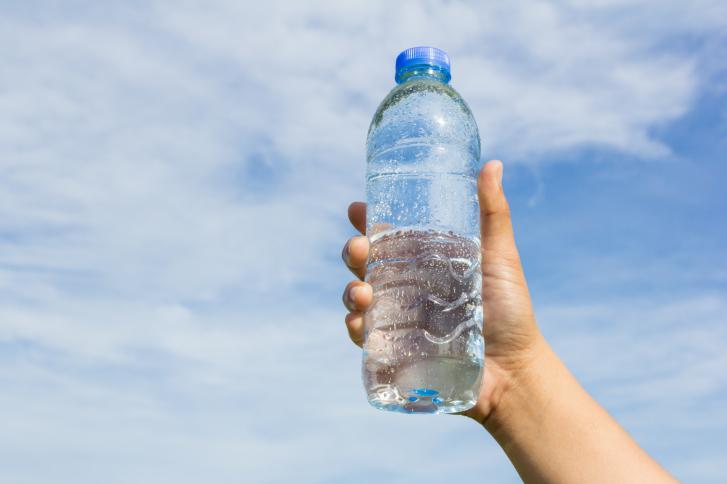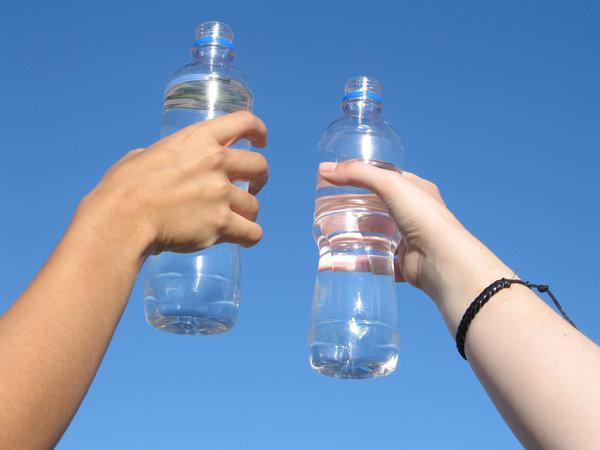The first image is the image on the left, the second image is the image on the right. Considering the images on both sides, is "Each image shows exactly one hand holding one water bottle." valid? Answer yes or no. No. The first image is the image on the left, the second image is the image on the right. For the images shown, is this caption "The left and right image contains the same number of water bottles and hands." true? Answer yes or no. No. 